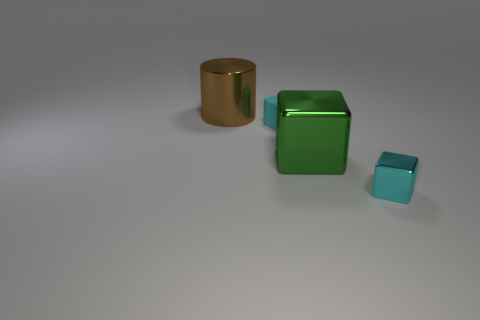What material is the large thing that is behind the small cyan object that is left of the tiny block in front of the large green metal cube?
Offer a very short reply. Metal. How many metal things are either brown objects or tiny objects?
Make the answer very short. 2. How many red objects are big objects or small shiny things?
Provide a short and direct response. 0. Is the color of the large thing that is behind the green metal object the same as the tiny metallic object?
Your response must be concise. No. Is the big cube made of the same material as the brown object?
Your response must be concise. Yes. Are there the same number of large brown shiny cylinders that are behind the brown cylinder and cyan rubber objects behind the tiny cyan rubber cube?
Provide a short and direct response. Yes. What is the material of the other tiny object that is the same shape as the tiny cyan metal thing?
Ensure brevity in your answer.  Rubber. There is a big thing behind the cyan object that is behind the tiny cyan block right of the cyan rubber thing; what is its shape?
Offer a very short reply. Cylinder. Is the number of small cyan rubber objects that are on the right side of the big green block greater than the number of cyan cubes?
Give a very brief answer. No. There is a small thing that is in front of the small cyan rubber object; does it have the same shape as the brown thing?
Provide a succinct answer. No. 